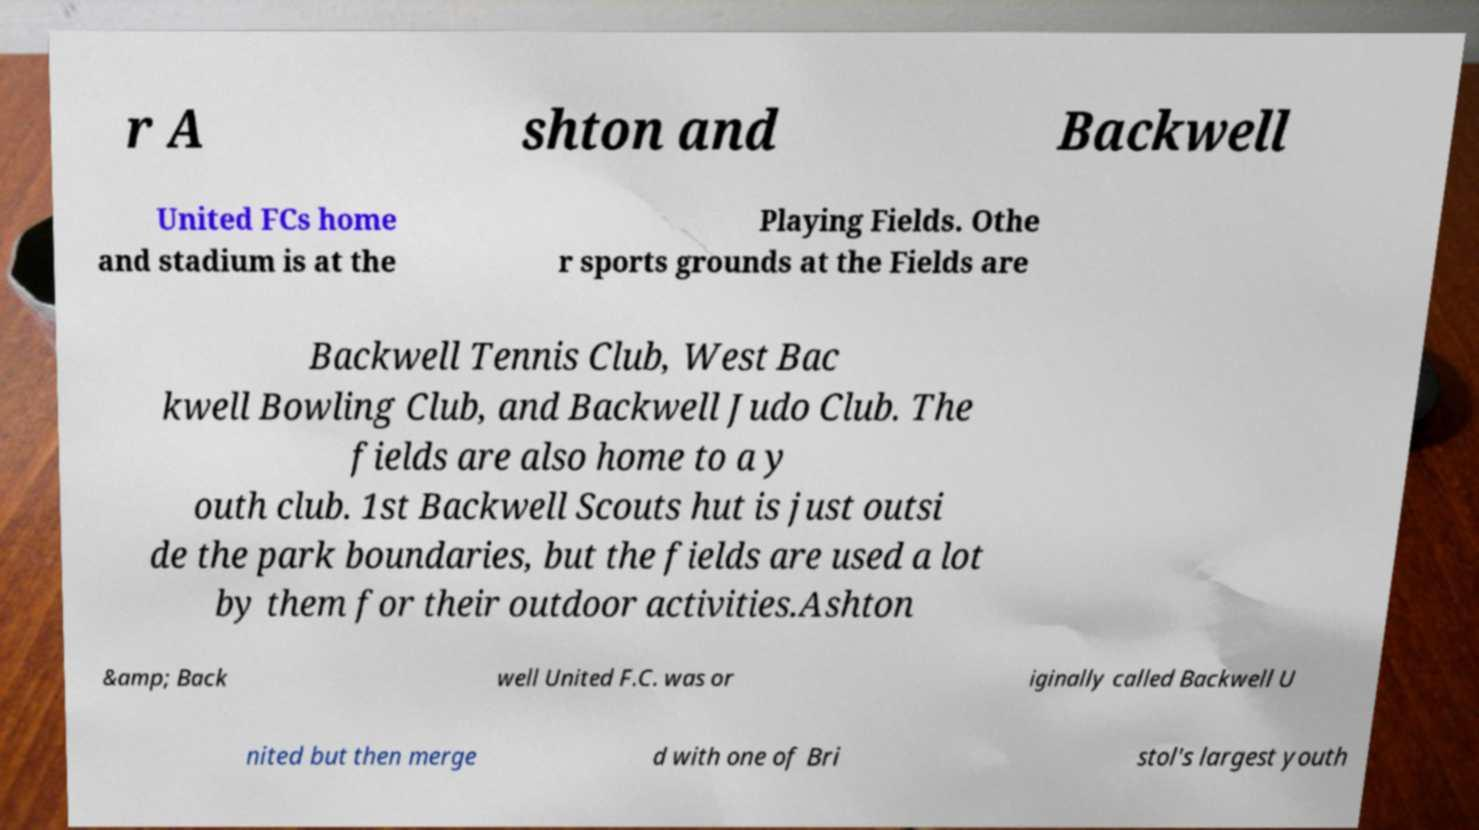Could you extract and type out the text from this image? r A shton and Backwell United FCs home and stadium is at the Playing Fields. Othe r sports grounds at the Fields are Backwell Tennis Club, West Bac kwell Bowling Club, and Backwell Judo Club. The fields are also home to a y outh club. 1st Backwell Scouts hut is just outsi de the park boundaries, but the fields are used a lot by them for their outdoor activities.Ashton &amp; Back well United F.C. was or iginally called Backwell U nited but then merge d with one of Bri stol's largest youth 